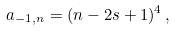<formula> <loc_0><loc_0><loc_500><loc_500>a _ { - 1 , n } = ( n - 2 s + 1 ) ^ { 4 } \, ,</formula> 